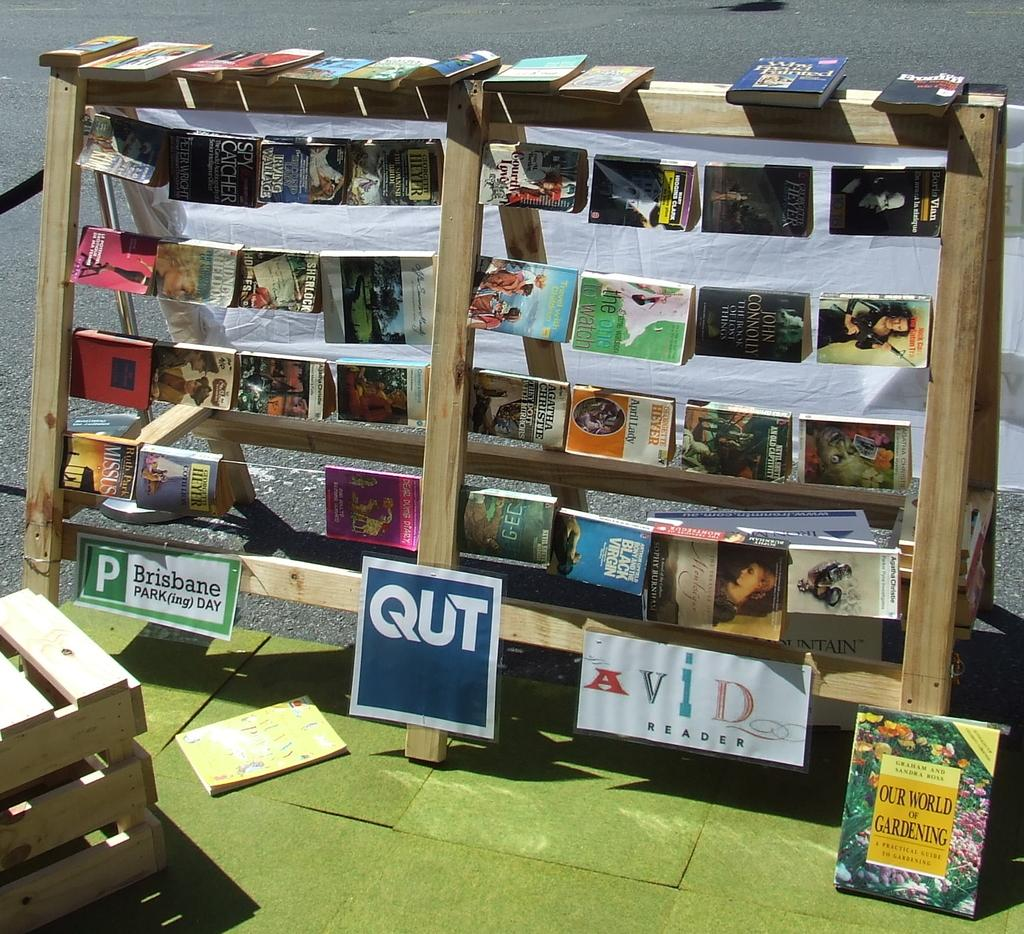<image>
Create a compact narrative representing the image presented. A copy of Our World of Gardening leans against a shelf holding other books. 